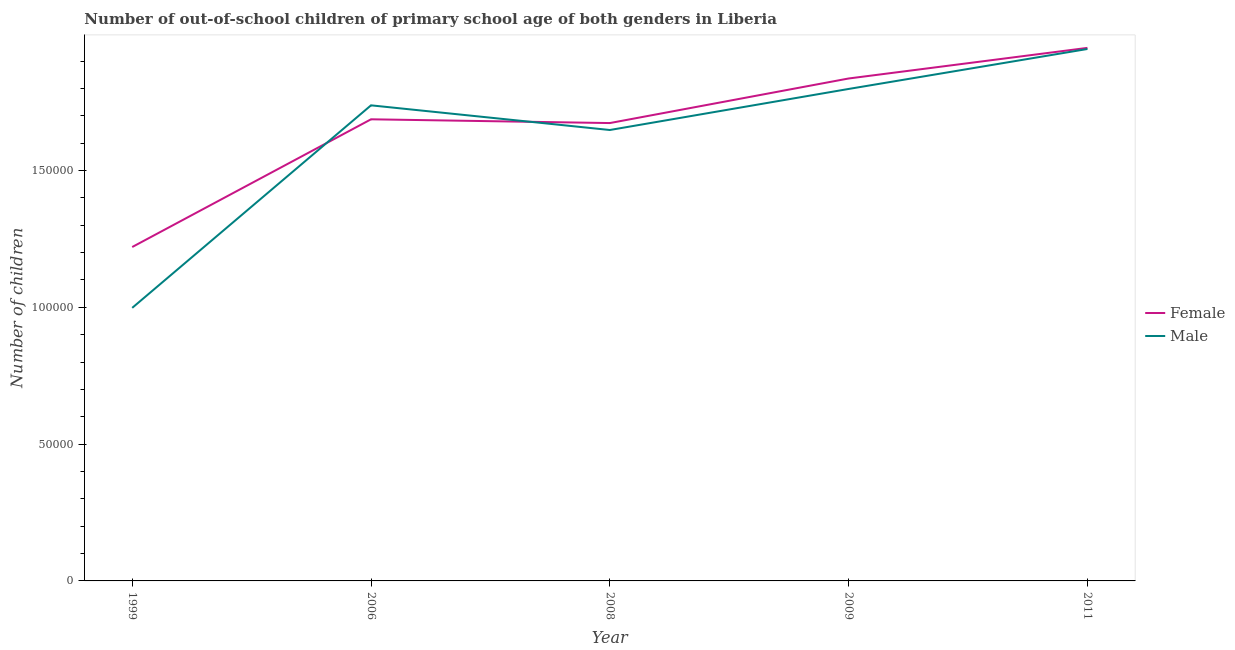How many different coloured lines are there?
Keep it short and to the point. 2. Is the number of lines equal to the number of legend labels?
Your answer should be very brief. Yes. What is the number of female out-of-school students in 2008?
Provide a short and direct response. 1.67e+05. Across all years, what is the maximum number of male out-of-school students?
Your answer should be very brief. 1.94e+05. Across all years, what is the minimum number of female out-of-school students?
Make the answer very short. 1.22e+05. In which year was the number of male out-of-school students maximum?
Your answer should be very brief. 2011. In which year was the number of female out-of-school students minimum?
Offer a terse response. 1999. What is the total number of female out-of-school students in the graph?
Offer a terse response. 8.37e+05. What is the difference between the number of female out-of-school students in 1999 and that in 2009?
Give a very brief answer. -6.16e+04. What is the difference between the number of male out-of-school students in 2009 and the number of female out-of-school students in 2006?
Give a very brief answer. 1.11e+04. What is the average number of male out-of-school students per year?
Make the answer very short. 1.63e+05. In the year 2009, what is the difference between the number of female out-of-school students and number of male out-of-school students?
Your response must be concise. 3826. What is the ratio of the number of male out-of-school students in 1999 to that in 2009?
Make the answer very short. 0.56. Is the difference between the number of female out-of-school students in 2006 and 2011 greater than the difference between the number of male out-of-school students in 2006 and 2011?
Give a very brief answer. No. What is the difference between the highest and the second highest number of female out-of-school students?
Your answer should be compact. 1.12e+04. What is the difference between the highest and the lowest number of male out-of-school students?
Offer a terse response. 9.46e+04. Does the number of female out-of-school students monotonically increase over the years?
Your answer should be very brief. No. Is the number of female out-of-school students strictly greater than the number of male out-of-school students over the years?
Give a very brief answer. No. How many lines are there?
Offer a very short reply. 2. How many years are there in the graph?
Give a very brief answer. 5. What is the difference between two consecutive major ticks on the Y-axis?
Your answer should be very brief. 5.00e+04. Are the values on the major ticks of Y-axis written in scientific E-notation?
Provide a short and direct response. No. Does the graph contain any zero values?
Keep it short and to the point. No. Does the graph contain grids?
Make the answer very short. No. Where does the legend appear in the graph?
Your response must be concise. Center right. What is the title of the graph?
Give a very brief answer. Number of out-of-school children of primary school age of both genders in Liberia. Does "By country of asylum" appear as one of the legend labels in the graph?
Your answer should be very brief. No. What is the label or title of the X-axis?
Offer a terse response. Year. What is the label or title of the Y-axis?
Provide a succinct answer. Number of children. What is the Number of children in Female in 1999?
Provide a succinct answer. 1.22e+05. What is the Number of children of Male in 1999?
Ensure brevity in your answer.  9.98e+04. What is the Number of children in Female in 2006?
Offer a very short reply. 1.69e+05. What is the Number of children in Male in 2006?
Ensure brevity in your answer.  1.74e+05. What is the Number of children of Female in 2008?
Provide a short and direct response. 1.67e+05. What is the Number of children of Male in 2008?
Make the answer very short. 1.65e+05. What is the Number of children of Female in 2009?
Provide a short and direct response. 1.84e+05. What is the Number of children in Male in 2009?
Make the answer very short. 1.80e+05. What is the Number of children of Female in 2011?
Keep it short and to the point. 1.95e+05. What is the Number of children in Male in 2011?
Keep it short and to the point. 1.94e+05. Across all years, what is the maximum Number of children of Female?
Offer a very short reply. 1.95e+05. Across all years, what is the maximum Number of children of Male?
Give a very brief answer. 1.94e+05. Across all years, what is the minimum Number of children of Female?
Your response must be concise. 1.22e+05. Across all years, what is the minimum Number of children of Male?
Your answer should be very brief. 9.98e+04. What is the total Number of children in Female in the graph?
Offer a terse response. 8.37e+05. What is the total Number of children of Male in the graph?
Your answer should be very brief. 8.13e+05. What is the difference between the Number of children of Female in 1999 and that in 2006?
Provide a short and direct response. -4.67e+04. What is the difference between the Number of children of Male in 1999 and that in 2006?
Your answer should be compact. -7.40e+04. What is the difference between the Number of children in Female in 1999 and that in 2008?
Make the answer very short. -4.53e+04. What is the difference between the Number of children in Male in 1999 and that in 2008?
Provide a short and direct response. -6.50e+04. What is the difference between the Number of children of Female in 1999 and that in 2009?
Offer a terse response. -6.16e+04. What is the difference between the Number of children in Male in 1999 and that in 2009?
Provide a short and direct response. -8.00e+04. What is the difference between the Number of children in Female in 1999 and that in 2011?
Your response must be concise. -7.28e+04. What is the difference between the Number of children in Male in 1999 and that in 2011?
Make the answer very short. -9.46e+04. What is the difference between the Number of children in Female in 2006 and that in 2008?
Your answer should be compact. 1375. What is the difference between the Number of children of Male in 2006 and that in 2008?
Provide a succinct answer. 9017. What is the difference between the Number of children of Female in 2006 and that in 2009?
Offer a terse response. -1.49e+04. What is the difference between the Number of children of Male in 2006 and that in 2009?
Offer a terse response. -5985. What is the difference between the Number of children of Female in 2006 and that in 2011?
Your response must be concise. -2.61e+04. What is the difference between the Number of children of Male in 2006 and that in 2011?
Offer a very short reply. -2.06e+04. What is the difference between the Number of children in Female in 2008 and that in 2009?
Keep it short and to the point. -1.63e+04. What is the difference between the Number of children in Male in 2008 and that in 2009?
Provide a short and direct response. -1.50e+04. What is the difference between the Number of children of Female in 2008 and that in 2011?
Ensure brevity in your answer.  -2.75e+04. What is the difference between the Number of children in Male in 2008 and that in 2011?
Give a very brief answer. -2.96e+04. What is the difference between the Number of children in Female in 2009 and that in 2011?
Give a very brief answer. -1.12e+04. What is the difference between the Number of children in Male in 2009 and that in 2011?
Give a very brief answer. -1.46e+04. What is the difference between the Number of children in Female in 1999 and the Number of children in Male in 2006?
Give a very brief answer. -5.18e+04. What is the difference between the Number of children of Female in 1999 and the Number of children of Male in 2008?
Your response must be concise. -4.28e+04. What is the difference between the Number of children of Female in 1999 and the Number of children of Male in 2009?
Your answer should be very brief. -5.78e+04. What is the difference between the Number of children of Female in 1999 and the Number of children of Male in 2011?
Make the answer very short. -7.24e+04. What is the difference between the Number of children of Female in 2006 and the Number of children of Male in 2008?
Keep it short and to the point. 3912. What is the difference between the Number of children of Female in 2006 and the Number of children of Male in 2009?
Ensure brevity in your answer.  -1.11e+04. What is the difference between the Number of children in Female in 2006 and the Number of children in Male in 2011?
Ensure brevity in your answer.  -2.57e+04. What is the difference between the Number of children of Female in 2008 and the Number of children of Male in 2009?
Provide a succinct answer. -1.25e+04. What is the difference between the Number of children in Female in 2008 and the Number of children in Male in 2011?
Provide a short and direct response. -2.71e+04. What is the difference between the Number of children of Female in 2009 and the Number of children of Male in 2011?
Give a very brief answer. -1.08e+04. What is the average Number of children in Female per year?
Ensure brevity in your answer.  1.67e+05. What is the average Number of children in Male per year?
Your answer should be very brief. 1.63e+05. In the year 1999, what is the difference between the Number of children in Female and Number of children in Male?
Offer a terse response. 2.22e+04. In the year 2006, what is the difference between the Number of children of Female and Number of children of Male?
Your answer should be very brief. -5105. In the year 2008, what is the difference between the Number of children in Female and Number of children in Male?
Your response must be concise. 2537. In the year 2009, what is the difference between the Number of children in Female and Number of children in Male?
Provide a short and direct response. 3826. In the year 2011, what is the difference between the Number of children of Female and Number of children of Male?
Ensure brevity in your answer.  407. What is the ratio of the Number of children in Female in 1999 to that in 2006?
Offer a very short reply. 0.72. What is the ratio of the Number of children in Male in 1999 to that in 2006?
Offer a very short reply. 0.57. What is the ratio of the Number of children of Female in 1999 to that in 2008?
Keep it short and to the point. 0.73. What is the ratio of the Number of children of Male in 1999 to that in 2008?
Keep it short and to the point. 0.61. What is the ratio of the Number of children of Female in 1999 to that in 2009?
Provide a short and direct response. 0.66. What is the ratio of the Number of children of Male in 1999 to that in 2009?
Keep it short and to the point. 0.56. What is the ratio of the Number of children of Female in 1999 to that in 2011?
Offer a very short reply. 0.63. What is the ratio of the Number of children in Male in 1999 to that in 2011?
Provide a succinct answer. 0.51. What is the ratio of the Number of children of Female in 2006 to that in 2008?
Offer a terse response. 1.01. What is the ratio of the Number of children in Male in 2006 to that in 2008?
Make the answer very short. 1.05. What is the ratio of the Number of children in Female in 2006 to that in 2009?
Provide a short and direct response. 0.92. What is the ratio of the Number of children of Male in 2006 to that in 2009?
Provide a succinct answer. 0.97. What is the ratio of the Number of children of Female in 2006 to that in 2011?
Make the answer very short. 0.87. What is the ratio of the Number of children of Male in 2006 to that in 2011?
Your response must be concise. 0.89. What is the ratio of the Number of children of Female in 2008 to that in 2009?
Provide a short and direct response. 0.91. What is the ratio of the Number of children in Male in 2008 to that in 2009?
Your answer should be very brief. 0.92. What is the ratio of the Number of children of Female in 2008 to that in 2011?
Give a very brief answer. 0.86. What is the ratio of the Number of children in Male in 2008 to that in 2011?
Provide a short and direct response. 0.85. What is the ratio of the Number of children of Female in 2009 to that in 2011?
Your response must be concise. 0.94. What is the ratio of the Number of children in Male in 2009 to that in 2011?
Make the answer very short. 0.92. What is the difference between the highest and the second highest Number of children in Female?
Your response must be concise. 1.12e+04. What is the difference between the highest and the second highest Number of children of Male?
Your answer should be very brief. 1.46e+04. What is the difference between the highest and the lowest Number of children in Female?
Provide a succinct answer. 7.28e+04. What is the difference between the highest and the lowest Number of children of Male?
Give a very brief answer. 9.46e+04. 